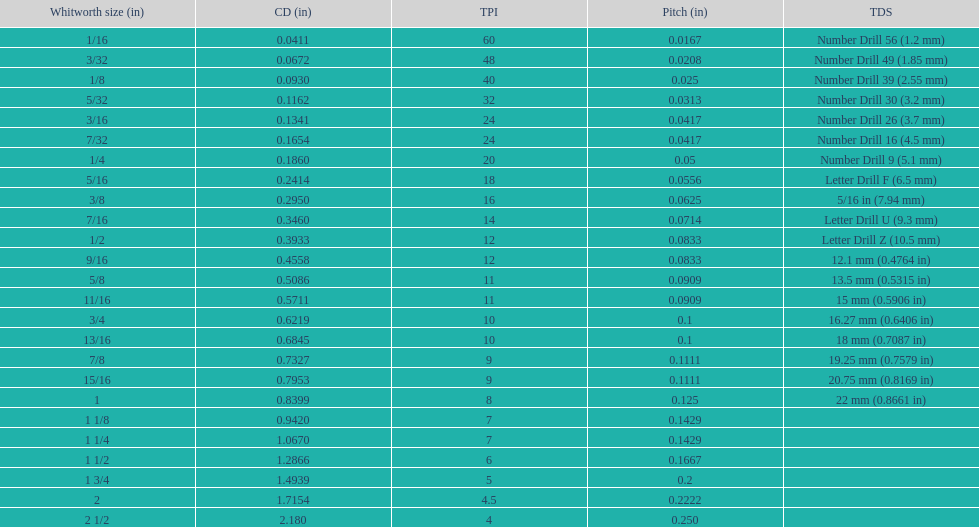Which whitworth size is the only one with 5 threads per inch? 1 3/4. 